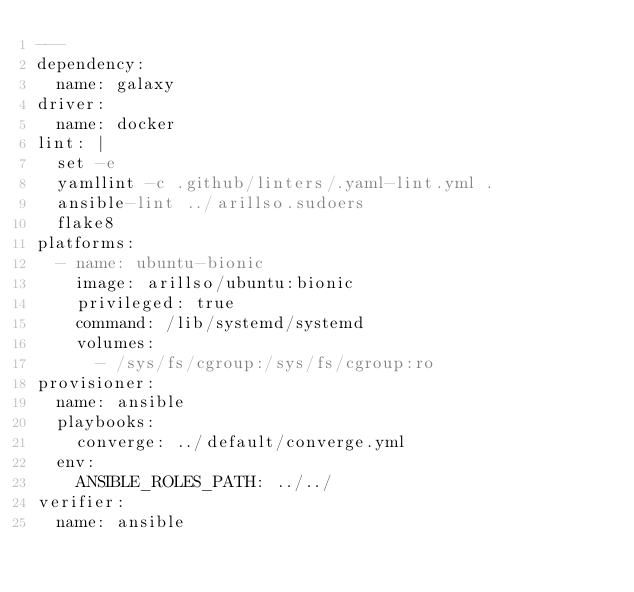<code> <loc_0><loc_0><loc_500><loc_500><_YAML_>---
dependency:
  name: galaxy
driver:
  name: docker
lint: |
  set -e
  yamllint -c .github/linters/.yaml-lint.yml .
  ansible-lint ../arillso.sudoers
  flake8
platforms:
  - name: ubuntu-bionic
    image: arillso/ubuntu:bionic
    privileged: true
    command: /lib/systemd/systemd
    volumes:
      - /sys/fs/cgroup:/sys/fs/cgroup:ro
provisioner:
  name: ansible
  playbooks:
    converge: ../default/converge.yml
  env:
    ANSIBLE_ROLES_PATH: ../../
verifier:
  name: ansible
</code> 